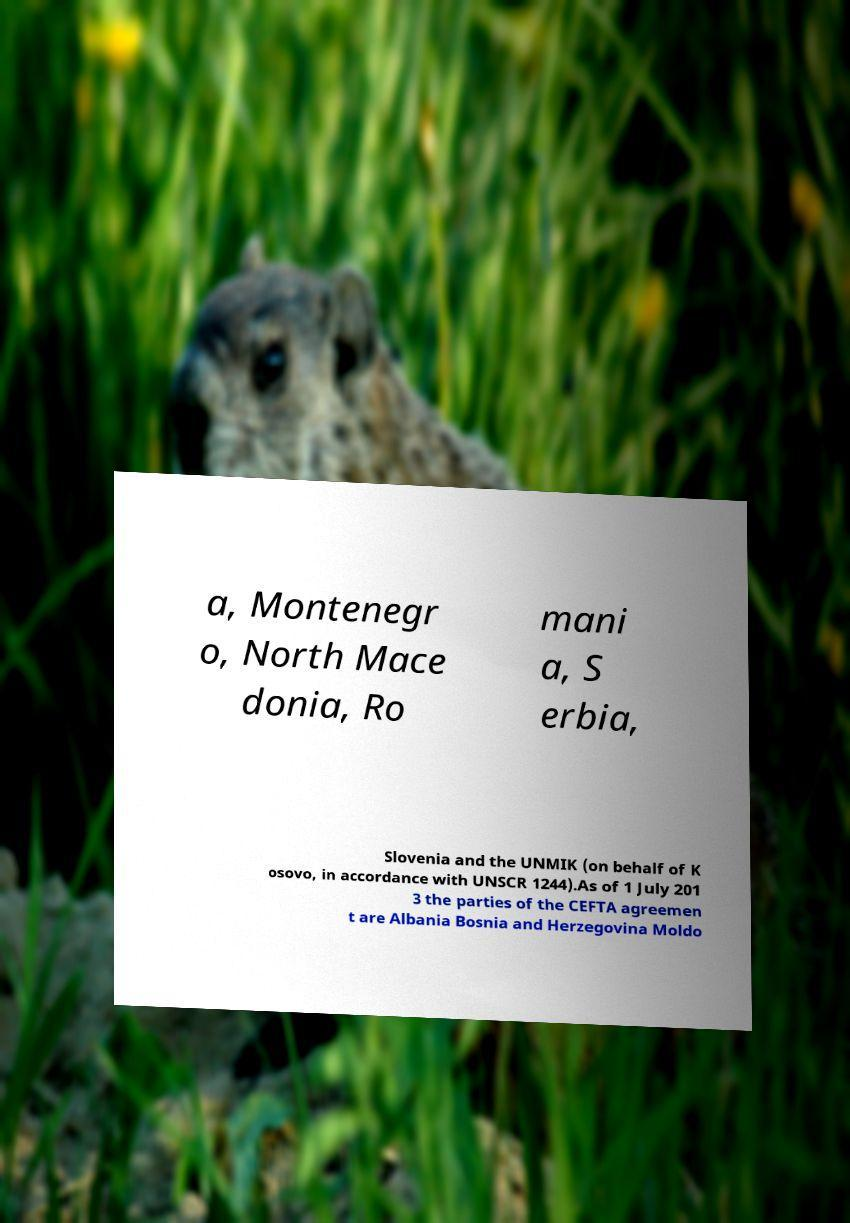Please read and relay the text visible in this image. What does it say? a, Montenegr o, North Mace donia, Ro mani a, S erbia, Slovenia and the UNMIK (on behalf of K osovo, in accordance with UNSCR 1244).As of 1 July 201 3 the parties of the CEFTA agreemen t are Albania Bosnia and Herzegovina Moldo 